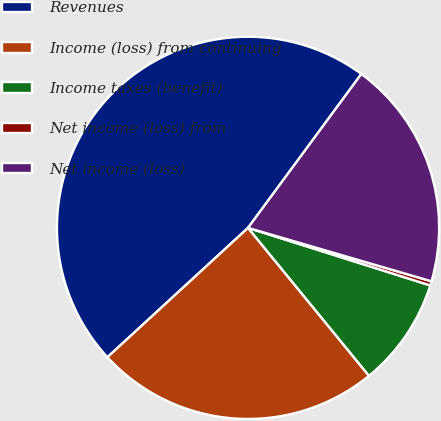<chart> <loc_0><loc_0><loc_500><loc_500><pie_chart><fcel>Revenues<fcel>Income (loss) from continuing<fcel>Income taxes (benefit)<fcel>Net income (loss) from<fcel>Net income (loss)<nl><fcel>46.94%<fcel>24.07%<fcel>9.22%<fcel>0.36%<fcel>19.41%<nl></chart> 